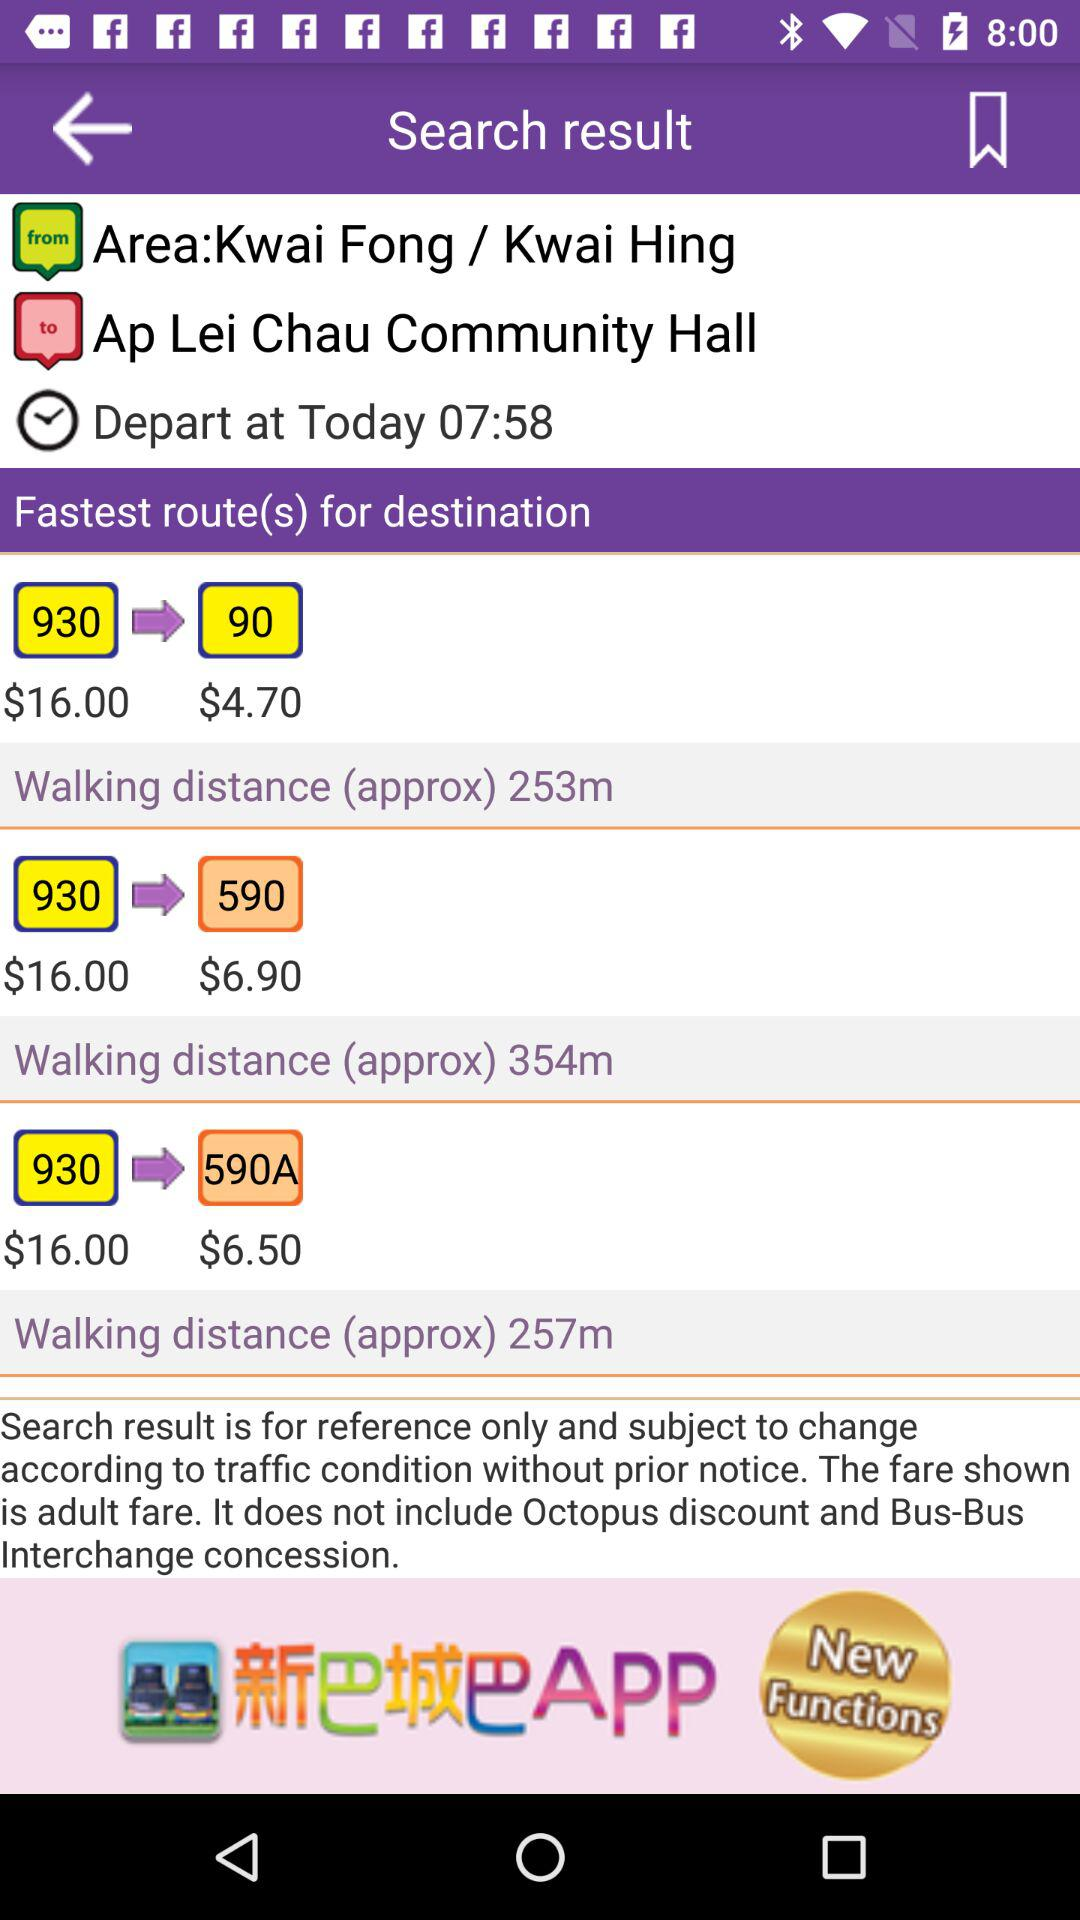What is the walking distance from 930 to 90? The walking distance is approximately 253 meters. 